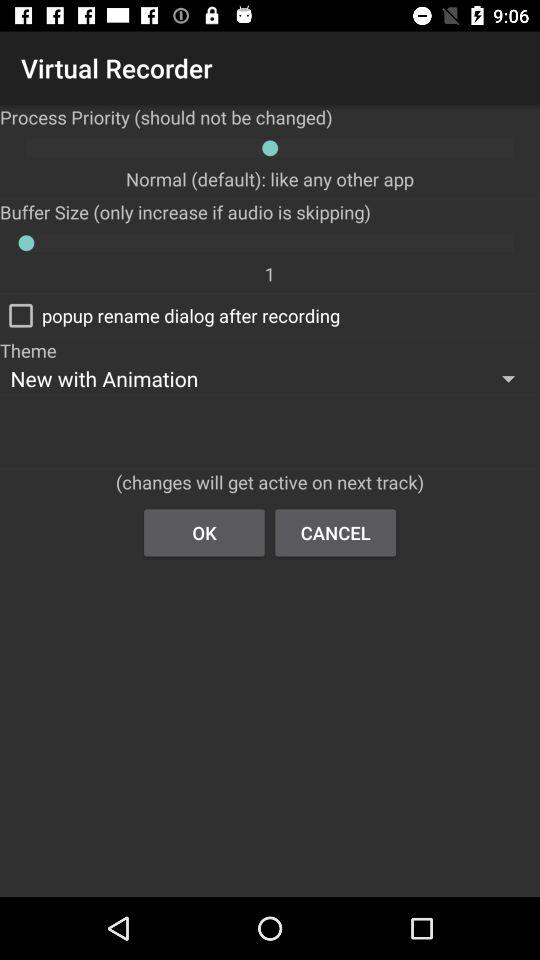What is the status of "popup rename dialog after recording"? The status of "popup rename dialog after recording" is "off". 